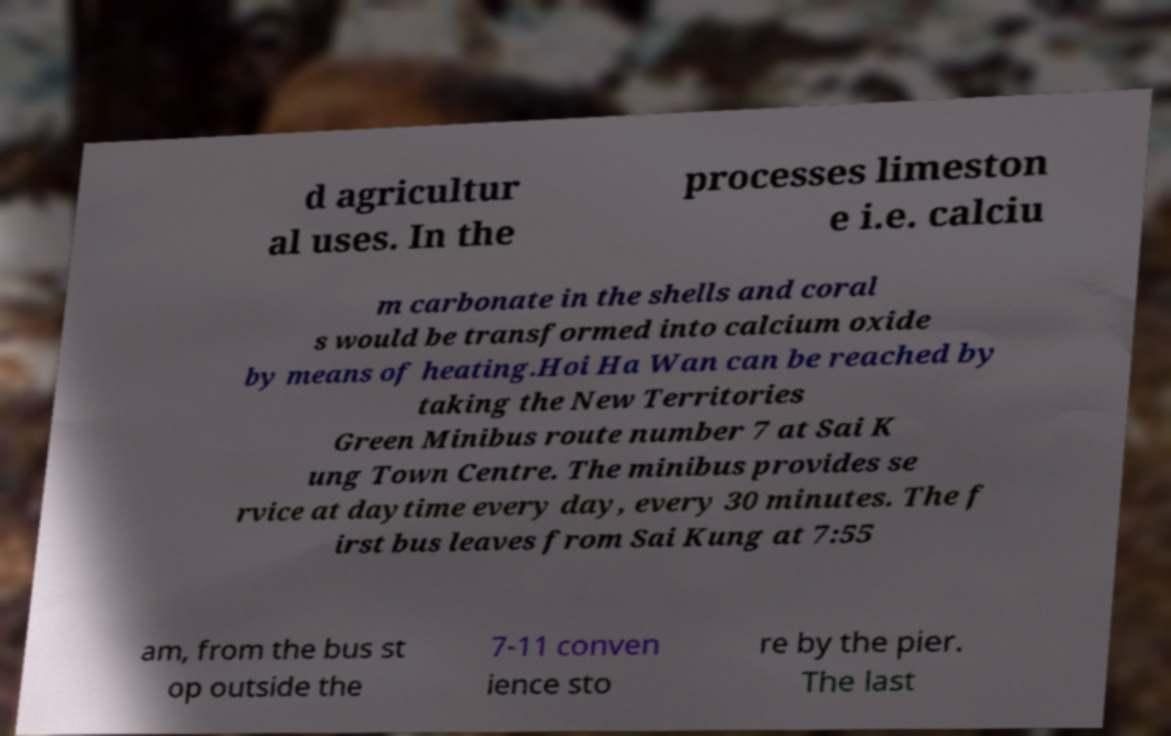For documentation purposes, I need the text within this image transcribed. Could you provide that? d agricultur al uses. In the processes limeston e i.e. calciu m carbonate in the shells and coral s would be transformed into calcium oxide by means of heating.Hoi Ha Wan can be reached by taking the New Territories Green Minibus route number 7 at Sai K ung Town Centre. The minibus provides se rvice at daytime every day, every 30 minutes. The f irst bus leaves from Sai Kung at 7:55 am, from the bus st op outside the 7-11 conven ience sto re by the pier. The last 